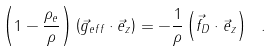Convert formula to latex. <formula><loc_0><loc_0><loc_500><loc_500>\left ( 1 - \frac { \rho _ { e } } { \rho } \right ) \left ( \vec { g } _ { e f f } \cdot \vec { e } _ { z } \right ) = - \frac { 1 } { \rho } \left ( \vec { f } _ { D } \cdot \vec { e } _ { z } \right ) \ .</formula> 